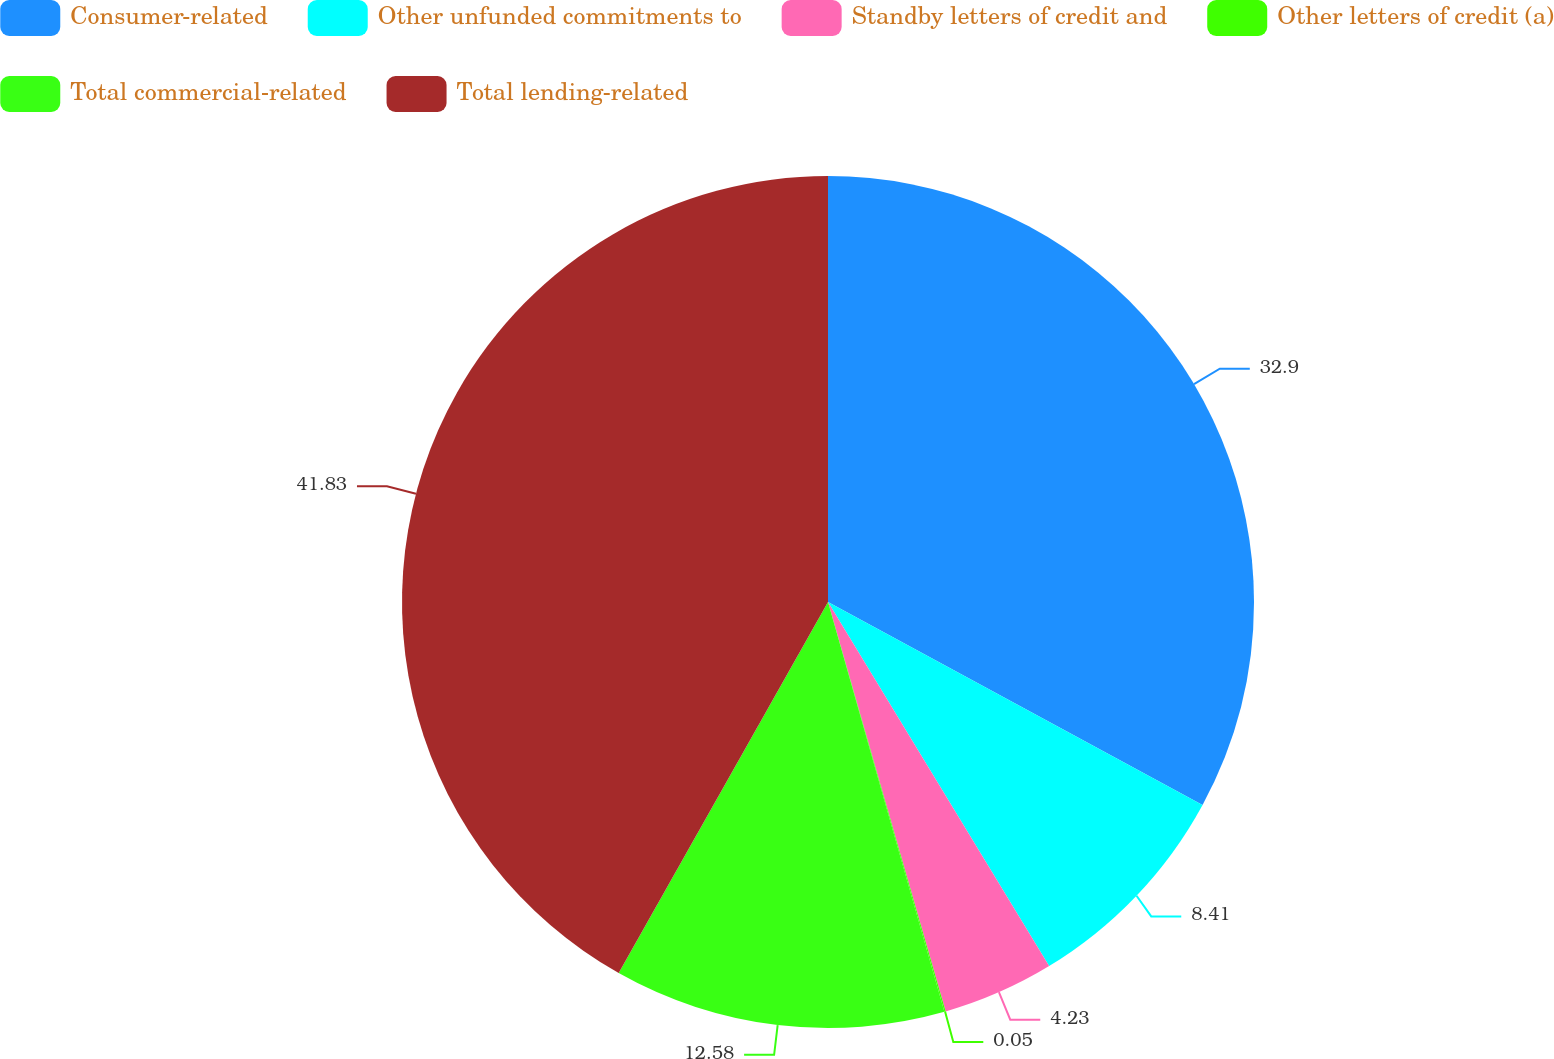Convert chart to OTSL. <chart><loc_0><loc_0><loc_500><loc_500><pie_chart><fcel>Consumer-related<fcel>Other unfunded commitments to<fcel>Standby letters of credit and<fcel>Other letters of credit (a)<fcel>Total commercial-related<fcel>Total lending-related<nl><fcel>32.9%<fcel>8.41%<fcel>4.23%<fcel>0.05%<fcel>12.58%<fcel>41.82%<nl></chart> 